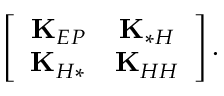Convert formula to latex. <formula><loc_0><loc_0><loc_500><loc_500>\left [ \begin{array} { c c } { K _ { E P } } & { K _ { * H } } \\ { K _ { H * } } & { K _ { H H } } \end{array} \right ] .</formula> 